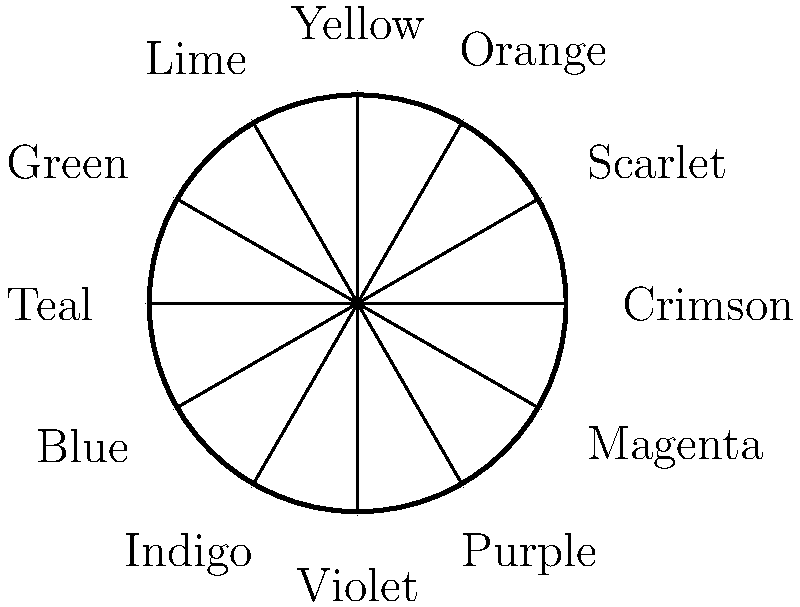In this color wheel representation of popular fabric dyes used in Renaissance Italy, which two complementary colors were often paired in noble attire to create a striking contrast? To answer this question, we need to consider the following steps:

1. Understand complementary colors: Complementary colors are pairs of colors that are opposite each other on the color wheel.

2. Identify the complementary pairs in the given color wheel:
   - Crimson and Teal
   - Scarlet and Blue
   - Orange and Indigo
   - Yellow and Violet
   - Lime and Purple
   - Green and Magenta

3. Consider historical context: In Renaissance Italy, nobles often wore bold, contrasting colors to display their wealth and status.

4. Among these complementary pairs, one stands out as particularly popular and striking in Renaissance fashion: Crimson and Teal.

5. Crimson was a highly prized color, often associated with power and nobility. It was derived from kermes, an expensive dye made from insects.

6. Teal, a blue-green color, was also valuable and symbolized wealth due to the cost of the dyes used to produce it.

7. The combination of Crimson and Teal created a rich, vibrant contrast that was favored by the nobility in their elaborate garments.
Answer: Crimson and Teal 